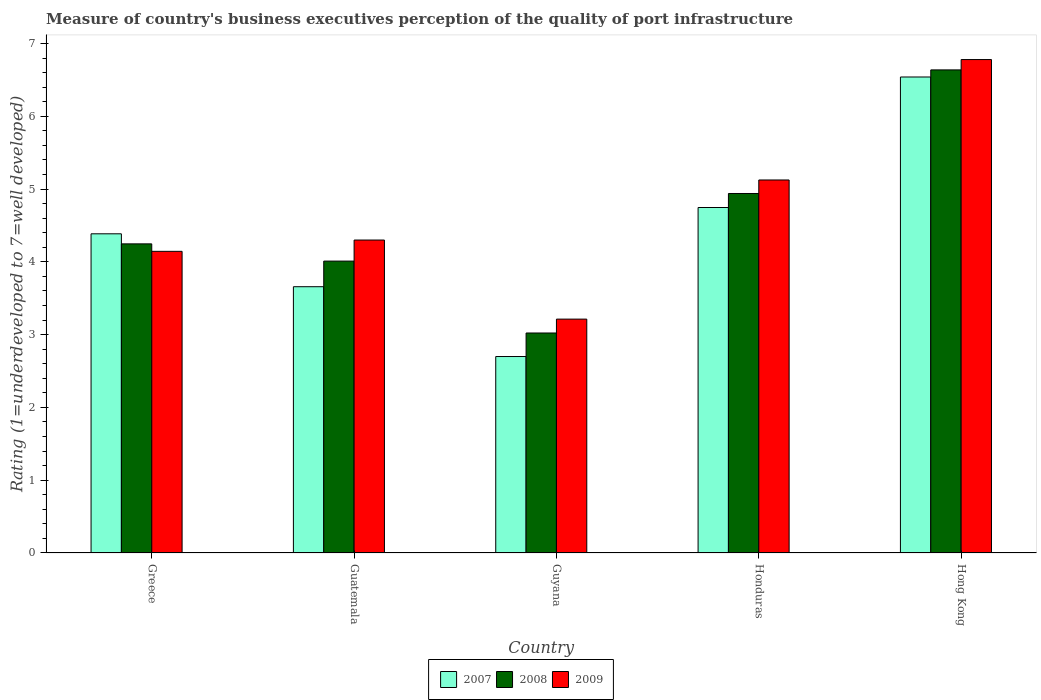How many different coloured bars are there?
Give a very brief answer. 3. How many groups of bars are there?
Offer a very short reply. 5. Are the number of bars per tick equal to the number of legend labels?
Make the answer very short. Yes. How many bars are there on the 3rd tick from the left?
Ensure brevity in your answer.  3. How many bars are there on the 1st tick from the right?
Offer a very short reply. 3. What is the label of the 3rd group of bars from the left?
Make the answer very short. Guyana. What is the ratings of the quality of port infrastructure in 2008 in Honduras?
Your answer should be compact. 4.94. Across all countries, what is the maximum ratings of the quality of port infrastructure in 2009?
Ensure brevity in your answer.  6.78. Across all countries, what is the minimum ratings of the quality of port infrastructure in 2009?
Ensure brevity in your answer.  3.21. In which country was the ratings of the quality of port infrastructure in 2009 maximum?
Provide a short and direct response. Hong Kong. In which country was the ratings of the quality of port infrastructure in 2009 minimum?
Your answer should be very brief. Guyana. What is the total ratings of the quality of port infrastructure in 2009 in the graph?
Offer a terse response. 23.56. What is the difference between the ratings of the quality of port infrastructure in 2007 in Greece and that in Hong Kong?
Keep it short and to the point. -2.15. What is the difference between the ratings of the quality of port infrastructure in 2009 in Guyana and the ratings of the quality of port infrastructure in 2007 in Greece?
Provide a short and direct response. -1.17. What is the average ratings of the quality of port infrastructure in 2009 per country?
Your answer should be very brief. 4.71. What is the difference between the ratings of the quality of port infrastructure of/in 2009 and ratings of the quality of port infrastructure of/in 2008 in Guatemala?
Provide a succinct answer. 0.29. What is the ratio of the ratings of the quality of port infrastructure in 2007 in Greece to that in Guyana?
Your answer should be compact. 1.62. Is the ratings of the quality of port infrastructure in 2008 in Guyana less than that in Honduras?
Your answer should be very brief. Yes. What is the difference between the highest and the second highest ratings of the quality of port infrastructure in 2009?
Your answer should be compact. -0.83. What is the difference between the highest and the lowest ratings of the quality of port infrastructure in 2009?
Keep it short and to the point. 3.57. Is the sum of the ratings of the quality of port infrastructure in 2007 in Guyana and Hong Kong greater than the maximum ratings of the quality of port infrastructure in 2009 across all countries?
Provide a short and direct response. Yes. Is it the case that in every country, the sum of the ratings of the quality of port infrastructure in 2008 and ratings of the quality of port infrastructure in 2007 is greater than the ratings of the quality of port infrastructure in 2009?
Provide a succinct answer. Yes. How many bars are there?
Keep it short and to the point. 15. What is the difference between two consecutive major ticks on the Y-axis?
Provide a succinct answer. 1. Are the values on the major ticks of Y-axis written in scientific E-notation?
Your answer should be very brief. No. How are the legend labels stacked?
Give a very brief answer. Horizontal. What is the title of the graph?
Your answer should be very brief. Measure of country's business executives perception of the quality of port infrastructure. Does "1960" appear as one of the legend labels in the graph?
Give a very brief answer. No. What is the label or title of the X-axis?
Your answer should be very brief. Country. What is the label or title of the Y-axis?
Your answer should be compact. Rating (1=underdeveloped to 7=well developed). What is the Rating (1=underdeveloped to 7=well developed) of 2007 in Greece?
Ensure brevity in your answer.  4.39. What is the Rating (1=underdeveloped to 7=well developed) of 2008 in Greece?
Offer a terse response. 4.25. What is the Rating (1=underdeveloped to 7=well developed) in 2009 in Greece?
Make the answer very short. 4.14. What is the Rating (1=underdeveloped to 7=well developed) in 2007 in Guatemala?
Your answer should be compact. 3.66. What is the Rating (1=underdeveloped to 7=well developed) in 2008 in Guatemala?
Your response must be concise. 4.01. What is the Rating (1=underdeveloped to 7=well developed) in 2009 in Guatemala?
Provide a succinct answer. 4.3. What is the Rating (1=underdeveloped to 7=well developed) in 2007 in Guyana?
Keep it short and to the point. 2.7. What is the Rating (1=underdeveloped to 7=well developed) in 2008 in Guyana?
Your response must be concise. 3.02. What is the Rating (1=underdeveloped to 7=well developed) in 2009 in Guyana?
Ensure brevity in your answer.  3.21. What is the Rating (1=underdeveloped to 7=well developed) of 2007 in Honduras?
Your answer should be compact. 4.75. What is the Rating (1=underdeveloped to 7=well developed) in 2008 in Honduras?
Your answer should be compact. 4.94. What is the Rating (1=underdeveloped to 7=well developed) of 2009 in Honduras?
Give a very brief answer. 5.12. What is the Rating (1=underdeveloped to 7=well developed) of 2007 in Hong Kong?
Offer a very short reply. 6.54. What is the Rating (1=underdeveloped to 7=well developed) in 2008 in Hong Kong?
Offer a very short reply. 6.64. What is the Rating (1=underdeveloped to 7=well developed) of 2009 in Hong Kong?
Your response must be concise. 6.78. Across all countries, what is the maximum Rating (1=underdeveloped to 7=well developed) of 2007?
Give a very brief answer. 6.54. Across all countries, what is the maximum Rating (1=underdeveloped to 7=well developed) of 2008?
Your response must be concise. 6.64. Across all countries, what is the maximum Rating (1=underdeveloped to 7=well developed) in 2009?
Keep it short and to the point. 6.78. Across all countries, what is the minimum Rating (1=underdeveloped to 7=well developed) of 2007?
Your answer should be compact. 2.7. Across all countries, what is the minimum Rating (1=underdeveloped to 7=well developed) of 2008?
Offer a terse response. 3.02. Across all countries, what is the minimum Rating (1=underdeveloped to 7=well developed) in 2009?
Provide a succinct answer. 3.21. What is the total Rating (1=underdeveloped to 7=well developed) in 2007 in the graph?
Your response must be concise. 22.03. What is the total Rating (1=underdeveloped to 7=well developed) in 2008 in the graph?
Offer a terse response. 22.86. What is the total Rating (1=underdeveloped to 7=well developed) of 2009 in the graph?
Ensure brevity in your answer.  23.56. What is the difference between the Rating (1=underdeveloped to 7=well developed) of 2007 in Greece and that in Guatemala?
Keep it short and to the point. 0.73. What is the difference between the Rating (1=underdeveloped to 7=well developed) in 2008 in Greece and that in Guatemala?
Keep it short and to the point. 0.24. What is the difference between the Rating (1=underdeveloped to 7=well developed) of 2009 in Greece and that in Guatemala?
Provide a succinct answer. -0.16. What is the difference between the Rating (1=underdeveloped to 7=well developed) of 2007 in Greece and that in Guyana?
Give a very brief answer. 1.69. What is the difference between the Rating (1=underdeveloped to 7=well developed) in 2008 in Greece and that in Guyana?
Ensure brevity in your answer.  1.22. What is the difference between the Rating (1=underdeveloped to 7=well developed) in 2009 in Greece and that in Guyana?
Make the answer very short. 0.93. What is the difference between the Rating (1=underdeveloped to 7=well developed) in 2007 in Greece and that in Honduras?
Offer a terse response. -0.36. What is the difference between the Rating (1=underdeveloped to 7=well developed) of 2008 in Greece and that in Honduras?
Your answer should be very brief. -0.69. What is the difference between the Rating (1=underdeveloped to 7=well developed) in 2009 in Greece and that in Honduras?
Your answer should be compact. -0.98. What is the difference between the Rating (1=underdeveloped to 7=well developed) of 2007 in Greece and that in Hong Kong?
Make the answer very short. -2.15. What is the difference between the Rating (1=underdeveloped to 7=well developed) in 2008 in Greece and that in Hong Kong?
Keep it short and to the point. -2.39. What is the difference between the Rating (1=underdeveloped to 7=well developed) of 2009 in Greece and that in Hong Kong?
Provide a short and direct response. -2.64. What is the difference between the Rating (1=underdeveloped to 7=well developed) of 2007 in Guatemala and that in Guyana?
Your answer should be very brief. 0.96. What is the difference between the Rating (1=underdeveloped to 7=well developed) in 2009 in Guatemala and that in Guyana?
Your answer should be compact. 1.09. What is the difference between the Rating (1=underdeveloped to 7=well developed) of 2007 in Guatemala and that in Honduras?
Make the answer very short. -1.09. What is the difference between the Rating (1=underdeveloped to 7=well developed) in 2008 in Guatemala and that in Honduras?
Make the answer very short. -0.93. What is the difference between the Rating (1=underdeveloped to 7=well developed) in 2009 in Guatemala and that in Honduras?
Your answer should be compact. -0.82. What is the difference between the Rating (1=underdeveloped to 7=well developed) of 2007 in Guatemala and that in Hong Kong?
Offer a very short reply. -2.88. What is the difference between the Rating (1=underdeveloped to 7=well developed) of 2008 in Guatemala and that in Hong Kong?
Make the answer very short. -2.63. What is the difference between the Rating (1=underdeveloped to 7=well developed) of 2009 in Guatemala and that in Hong Kong?
Keep it short and to the point. -2.48. What is the difference between the Rating (1=underdeveloped to 7=well developed) of 2007 in Guyana and that in Honduras?
Offer a terse response. -2.05. What is the difference between the Rating (1=underdeveloped to 7=well developed) in 2008 in Guyana and that in Honduras?
Provide a short and direct response. -1.92. What is the difference between the Rating (1=underdeveloped to 7=well developed) of 2009 in Guyana and that in Honduras?
Your answer should be compact. -1.91. What is the difference between the Rating (1=underdeveloped to 7=well developed) in 2007 in Guyana and that in Hong Kong?
Your response must be concise. -3.84. What is the difference between the Rating (1=underdeveloped to 7=well developed) of 2008 in Guyana and that in Hong Kong?
Your response must be concise. -3.61. What is the difference between the Rating (1=underdeveloped to 7=well developed) in 2009 in Guyana and that in Hong Kong?
Make the answer very short. -3.57. What is the difference between the Rating (1=underdeveloped to 7=well developed) of 2007 in Honduras and that in Hong Kong?
Provide a short and direct response. -1.79. What is the difference between the Rating (1=underdeveloped to 7=well developed) in 2008 in Honduras and that in Hong Kong?
Provide a succinct answer. -1.7. What is the difference between the Rating (1=underdeveloped to 7=well developed) of 2009 in Honduras and that in Hong Kong?
Your response must be concise. -1.65. What is the difference between the Rating (1=underdeveloped to 7=well developed) in 2007 in Greece and the Rating (1=underdeveloped to 7=well developed) in 2008 in Guatemala?
Ensure brevity in your answer.  0.38. What is the difference between the Rating (1=underdeveloped to 7=well developed) in 2007 in Greece and the Rating (1=underdeveloped to 7=well developed) in 2009 in Guatemala?
Provide a short and direct response. 0.09. What is the difference between the Rating (1=underdeveloped to 7=well developed) in 2008 in Greece and the Rating (1=underdeveloped to 7=well developed) in 2009 in Guatemala?
Your answer should be compact. -0.05. What is the difference between the Rating (1=underdeveloped to 7=well developed) in 2007 in Greece and the Rating (1=underdeveloped to 7=well developed) in 2008 in Guyana?
Your answer should be very brief. 1.36. What is the difference between the Rating (1=underdeveloped to 7=well developed) of 2007 in Greece and the Rating (1=underdeveloped to 7=well developed) of 2009 in Guyana?
Keep it short and to the point. 1.17. What is the difference between the Rating (1=underdeveloped to 7=well developed) of 2008 in Greece and the Rating (1=underdeveloped to 7=well developed) of 2009 in Guyana?
Provide a succinct answer. 1.03. What is the difference between the Rating (1=underdeveloped to 7=well developed) of 2007 in Greece and the Rating (1=underdeveloped to 7=well developed) of 2008 in Honduras?
Offer a terse response. -0.55. What is the difference between the Rating (1=underdeveloped to 7=well developed) in 2007 in Greece and the Rating (1=underdeveloped to 7=well developed) in 2009 in Honduras?
Provide a succinct answer. -0.74. What is the difference between the Rating (1=underdeveloped to 7=well developed) of 2008 in Greece and the Rating (1=underdeveloped to 7=well developed) of 2009 in Honduras?
Offer a very short reply. -0.88. What is the difference between the Rating (1=underdeveloped to 7=well developed) in 2007 in Greece and the Rating (1=underdeveloped to 7=well developed) in 2008 in Hong Kong?
Your answer should be compact. -2.25. What is the difference between the Rating (1=underdeveloped to 7=well developed) in 2007 in Greece and the Rating (1=underdeveloped to 7=well developed) in 2009 in Hong Kong?
Your answer should be compact. -2.39. What is the difference between the Rating (1=underdeveloped to 7=well developed) in 2008 in Greece and the Rating (1=underdeveloped to 7=well developed) in 2009 in Hong Kong?
Give a very brief answer. -2.53. What is the difference between the Rating (1=underdeveloped to 7=well developed) in 2007 in Guatemala and the Rating (1=underdeveloped to 7=well developed) in 2008 in Guyana?
Give a very brief answer. 0.64. What is the difference between the Rating (1=underdeveloped to 7=well developed) in 2007 in Guatemala and the Rating (1=underdeveloped to 7=well developed) in 2009 in Guyana?
Your answer should be very brief. 0.45. What is the difference between the Rating (1=underdeveloped to 7=well developed) of 2008 in Guatemala and the Rating (1=underdeveloped to 7=well developed) of 2009 in Guyana?
Keep it short and to the point. 0.8. What is the difference between the Rating (1=underdeveloped to 7=well developed) in 2007 in Guatemala and the Rating (1=underdeveloped to 7=well developed) in 2008 in Honduras?
Make the answer very short. -1.28. What is the difference between the Rating (1=underdeveloped to 7=well developed) of 2007 in Guatemala and the Rating (1=underdeveloped to 7=well developed) of 2009 in Honduras?
Your answer should be compact. -1.47. What is the difference between the Rating (1=underdeveloped to 7=well developed) in 2008 in Guatemala and the Rating (1=underdeveloped to 7=well developed) in 2009 in Honduras?
Make the answer very short. -1.11. What is the difference between the Rating (1=underdeveloped to 7=well developed) in 2007 in Guatemala and the Rating (1=underdeveloped to 7=well developed) in 2008 in Hong Kong?
Provide a succinct answer. -2.98. What is the difference between the Rating (1=underdeveloped to 7=well developed) in 2007 in Guatemala and the Rating (1=underdeveloped to 7=well developed) in 2009 in Hong Kong?
Provide a short and direct response. -3.12. What is the difference between the Rating (1=underdeveloped to 7=well developed) of 2008 in Guatemala and the Rating (1=underdeveloped to 7=well developed) of 2009 in Hong Kong?
Provide a short and direct response. -2.77. What is the difference between the Rating (1=underdeveloped to 7=well developed) of 2007 in Guyana and the Rating (1=underdeveloped to 7=well developed) of 2008 in Honduras?
Make the answer very short. -2.24. What is the difference between the Rating (1=underdeveloped to 7=well developed) in 2007 in Guyana and the Rating (1=underdeveloped to 7=well developed) in 2009 in Honduras?
Make the answer very short. -2.43. What is the difference between the Rating (1=underdeveloped to 7=well developed) of 2008 in Guyana and the Rating (1=underdeveloped to 7=well developed) of 2009 in Honduras?
Offer a terse response. -2.1. What is the difference between the Rating (1=underdeveloped to 7=well developed) in 2007 in Guyana and the Rating (1=underdeveloped to 7=well developed) in 2008 in Hong Kong?
Offer a very short reply. -3.94. What is the difference between the Rating (1=underdeveloped to 7=well developed) of 2007 in Guyana and the Rating (1=underdeveloped to 7=well developed) of 2009 in Hong Kong?
Ensure brevity in your answer.  -4.08. What is the difference between the Rating (1=underdeveloped to 7=well developed) in 2008 in Guyana and the Rating (1=underdeveloped to 7=well developed) in 2009 in Hong Kong?
Your answer should be compact. -3.76. What is the difference between the Rating (1=underdeveloped to 7=well developed) in 2007 in Honduras and the Rating (1=underdeveloped to 7=well developed) in 2008 in Hong Kong?
Give a very brief answer. -1.89. What is the difference between the Rating (1=underdeveloped to 7=well developed) of 2007 in Honduras and the Rating (1=underdeveloped to 7=well developed) of 2009 in Hong Kong?
Your answer should be very brief. -2.03. What is the difference between the Rating (1=underdeveloped to 7=well developed) of 2008 in Honduras and the Rating (1=underdeveloped to 7=well developed) of 2009 in Hong Kong?
Keep it short and to the point. -1.84. What is the average Rating (1=underdeveloped to 7=well developed) of 2007 per country?
Your response must be concise. 4.41. What is the average Rating (1=underdeveloped to 7=well developed) of 2008 per country?
Offer a terse response. 4.57. What is the average Rating (1=underdeveloped to 7=well developed) in 2009 per country?
Give a very brief answer. 4.71. What is the difference between the Rating (1=underdeveloped to 7=well developed) in 2007 and Rating (1=underdeveloped to 7=well developed) in 2008 in Greece?
Make the answer very short. 0.14. What is the difference between the Rating (1=underdeveloped to 7=well developed) in 2007 and Rating (1=underdeveloped to 7=well developed) in 2009 in Greece?
Your answer should be compact. 0.24. What is the difference between the Rating (1=underdeveloped to 7=well developed) of 2008 and Rating (1=underdeveloped to 7=well developed) of 2009 in Greece?
Provide a succinct answer. 0.1. What is the difference between the Rating (1=underdeveloped to 7=well developed) in 2007 and Rating (1=underdeveloped to 7=well developed) in 2008 in Guatemala?
Your answer should be compact. -0.35. What is the difference between the Rating (1=underdeveloped to 7=well developed) of 2007 and Rating (1=underdeveloped to 7=well developed) of 2009 in Guatemala?
Your answer should be compact. -0.64. What is the difference between the Rating (1=underdeveloped to 7=well developed) in 2008 and Rating (1=underdeveloped to 7=well developed) in 2009 in Guatemala?
Provide a succinct answer. -0.29. What is the difference between the Rating (1=underdeveloped to 7=well developed) in 2007 and Rating (1=underdeveloped to 7=well developed) in 2008 in Guyana?
Give a very brief answer. -0.32. What is the difference between the Rating (1=underdeveloped to 7=well developed) of 2007 and Rating (1=underdeveloped to 7=well developed) of 2009 in Guyana?
Your response must be concise. -0.51. What is the difference between the Rating (1=underdeveloped to 7=well developed) in 2008 and Rating (1=underdeveloped to 7=well developed) in 2009 in Guyana?
Your answer should be compact. -0.19. What is the difference between the Rating (1=underdeveloped to 7=well developed) in 2007 and Rating (1=underdeveloped to 7=well developed) in 2008 in Honduras?
Your answer should be compact. -0.19. What is the difference between the Rating (1=underdeveloped to 7=well developed) in 2007 and Rating (1=underdeveloped to 7=well developed) in 2009 in Honduras?
Your answer should be compact. -0.38. What is the difference between the Rating (1=underdeveloped to 7=well developed) of 2008 and Rating (1=underdeveloped to 7=well developed) of 2009 in Honduras?
Offer a terse response. -0.19. What is the difference between the Rating (1=underdeveloped to 7=well developed) of 2007 and Rating (1=underdeveloped to 7=well developed) of 2008 in Hong Kong?
Your answer should be very brief. -0.1. What is the difference between the Rating (1=underdeveloped to 7=well developed) in 2007 and Rating (1=underdeveloped to 7=well developed) in 2009 in Hong Kong?
Keep it short and to the point. -0.24. What is the difference between the Rating (1=underdeveloped to 7=well developed) of 2008 and Rating (1=underdeveloped to 7=well developed) of 2009 in Hong Kong?
Offer a very short reply. -0.14. What is the ratio of the Rating (1=underdeveloped to 7=well developed) in 2007 in Greece to that in Guatemala?
Your answer should be very brief. 1.2. What is the ratio of the Rating (1=underdeveloped to 7=well developed) of 2008 in Greece to that in Guatemala?
Offer a terse response. 1.06. What is the ratio of the Rating (1=underdeveloped to 7=well developed) in 2009 in Greece to that in Guatemala?
Offer a terse response. 0.96. What is the ratio of the Rating (1=underdeveloped to 7=well developed) of 2007 in Greece to that in Guyana?
Offer a terse response. 1.62. What is the ratio of the Rating (1=underdeveloped to 7=well developed) in 2008 in Greece to that in Guyana?
Give a very brief answer. 1.41. What is the ratio of the Rating (1=underdeveloped to 7=well developed) of 2009 in Greece to that in Guyana?
Offer a very short reply. 1.29. What is the ratio of the Rating (1=underdeveloped to 7=well developed) of 2007 in Greece to that in Honduras?
Your answer should be compact. 0.92. What is the ratio of the Rating (1=underdeveloped to 7=well developed) in 2008 in Greece to that in Honduras?
Make the answer very short. 0.86. What is the ratio of the Rating (1=underdeveloped to 7=well developed) of 2009 in Greece to that in Honduras?
Your answer should be compact. 0.81. What is the ratio of the Rating (1=underdeveloped to 7=well developed) of 2007 in Greece to that in Hong Kong?
Make the answer very short. 0.67. What is the ratio of the Rating (1=underdeveloped to 7=well developed) in 2008 in Greece to that in Hong Kong?
Make the answer very short. 0.64. What is the ratio of the Rating (1=underdeveloped to 7=well developed) of 2009 in Greece to that in Hong Kong?
Make the answer very short. 0.61. What is the ratio of the Rating (1=underdeveloped to 7=well developed) of 2007 in Guatemala to that in Guyana?
Your answer should be compact. 1.36. What is the ratio of the Rating (1=underdeveloped to 7=well developed) in 2008 in Guatemala to that in Guyana?
Keep it short and to the point. 1.33. What is the ratio of the Rating (1=underdeveloped to 7=well developed) of 2009 in Guatemala to that in Guyana?
Your response must be concise. 1.34. What is the ratio of the Rating (1=underdeveloped to 7=well developed) in 2007 in Guatemala to that in Honduras?
Provide a short and direct response. 0.77. What is the ratio of the Rating (1=underdeveloped to 7=well developed) in 2008 in Guatemala to that in Honduras?
Ensure brevity in your answer.  0.81. What is the ratio of the Rating (1=underdeveloped to 7=well developed) in 2009 in Guatemala to that in Honduras?
Your response must be concise. 0.84. What is the ratio of the Rating (1=underdeveloped to 7=well developed) in 2007 in Guatemala to that in Hong Kong?
Make the answer very short. 0.56. What is the ratio of the Rating (1=underdeveloped to 7=well developed) of 2008 in Guatemala to that in Hong Kong?
Provide a succinct answer. 0.6. What is the ratio of the Rating (1=underdeveloped to 7=well developed) in 2009 in Guatemala to that in Hong Kong?
Provide a short and direct response. 0.63. What is the ratio of the Rating (1=underdeveloped to 7=well developed) in 2007 in Guyana to that in Honduras?
Your answer should be very brief. 0.57. What is the ratio of the Rating (1=underdeveloped to 7=well developed) of 2008 in Guyana to that in Honduras?
Your answer should be very brief. 0.61. What is the ratio of the Rating (1=underdeveloped to 7=well developed) of 2009 in Guyana to that in Honduras?
Offer a very short reply. 0.63. What is the ratio of the Rating (1=underdeveloped to 7=well developed) in 2007 in Guyana to that in Hong Kong?
Offer a terse response. 0.41. What is the ratio of the Rating (1=underdeveloped to 7=well developed) in 2008 in Guyana to that in Hong Kong?
Your response must be concise. 0.46. What is the ratio of the Rating (1=underdeveloped to 7=well developed) in 2009 in Guyana to that in Hong Kong?
Your answer should be very brief. 0.47. What is the ratio of the Rating (1=underdeveloped to 7=well developed) of 2007 in Honduras to that in Hong Kong?
Your answer should be very brief. 0.73. What is the ratio of the Rating (1=underdeveloped to 7=well developed) in 2008 in Honduras to that in Hong Kong?
Provide a succinct answer. 0.74. What is the ratio of the Rating (1=underdeveloped to 7=well developed) of 2009 in Honduras to that in Hong Kong?
Provide a succinct answer. 0.76. What is the difference between the highest and the second highest Rating (1=underdeveloped to 7=well developed) in 2007?
Keep it short and to the point. 1.79. What is the difference between the highest and the second highest Rating (1=underdeveloped to 7=well developed) of 2008?
Offer a terse response. 1.7. What is the difference between the highest and the second highest Rating (1=underdeveloped to 7=well developed) in 2009?
Provide a short and direct response. 1.65. What is the difference between the highest and the lowest Rating (1=underdeveloped to 7=well developed) in 2007?
Your answer should be compact. 3.84. What is the difference between the highest and the lowest Rating (1=underdeveloped to 7=well developed) of 2008?
Give a very brief answer. 3.61. What is the difference between the highest and the lowest Rating (1=underdeveloped to 7=well developed) in 2009?
Give a very brief answer. 3.57. 